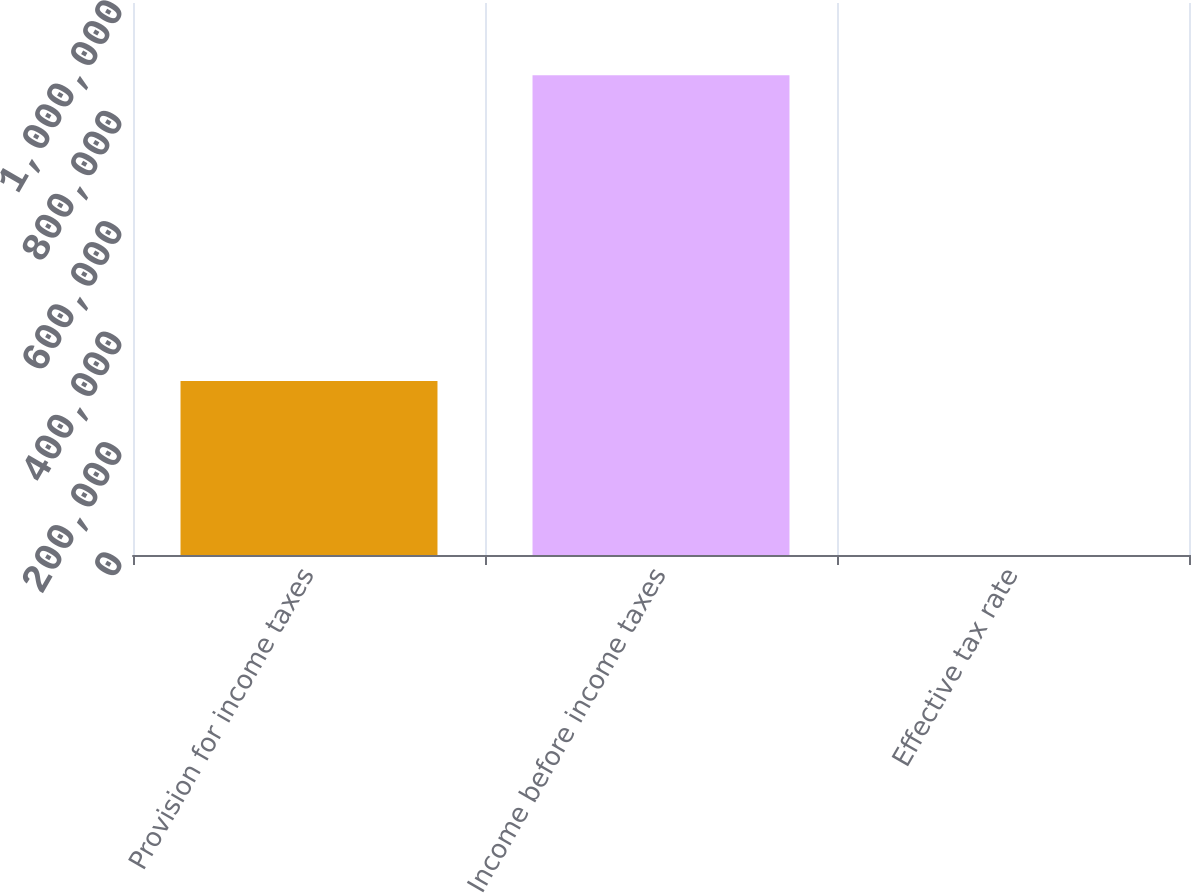Convert chart. <chart><loc_0><loc_0><loc_500><loc_500><bar_chart><fcel>Provision for income taxes<fcel>Income before income taxes<fcel>Effective tax rate<nl><fcel>315309<fcel>869332<fcel>36.3<nl></chart> 